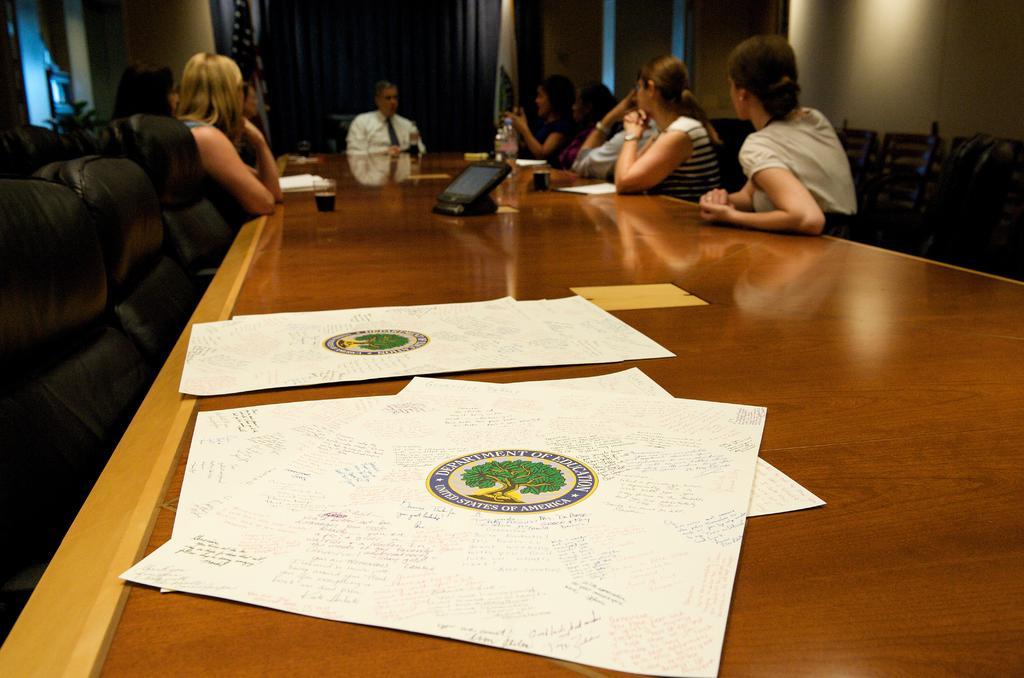In one or two sentences, can you explain what this image depicts? In this image I can see the group of people sitting in-front of the table. On the table there are papers,glasses,and the bottle. 